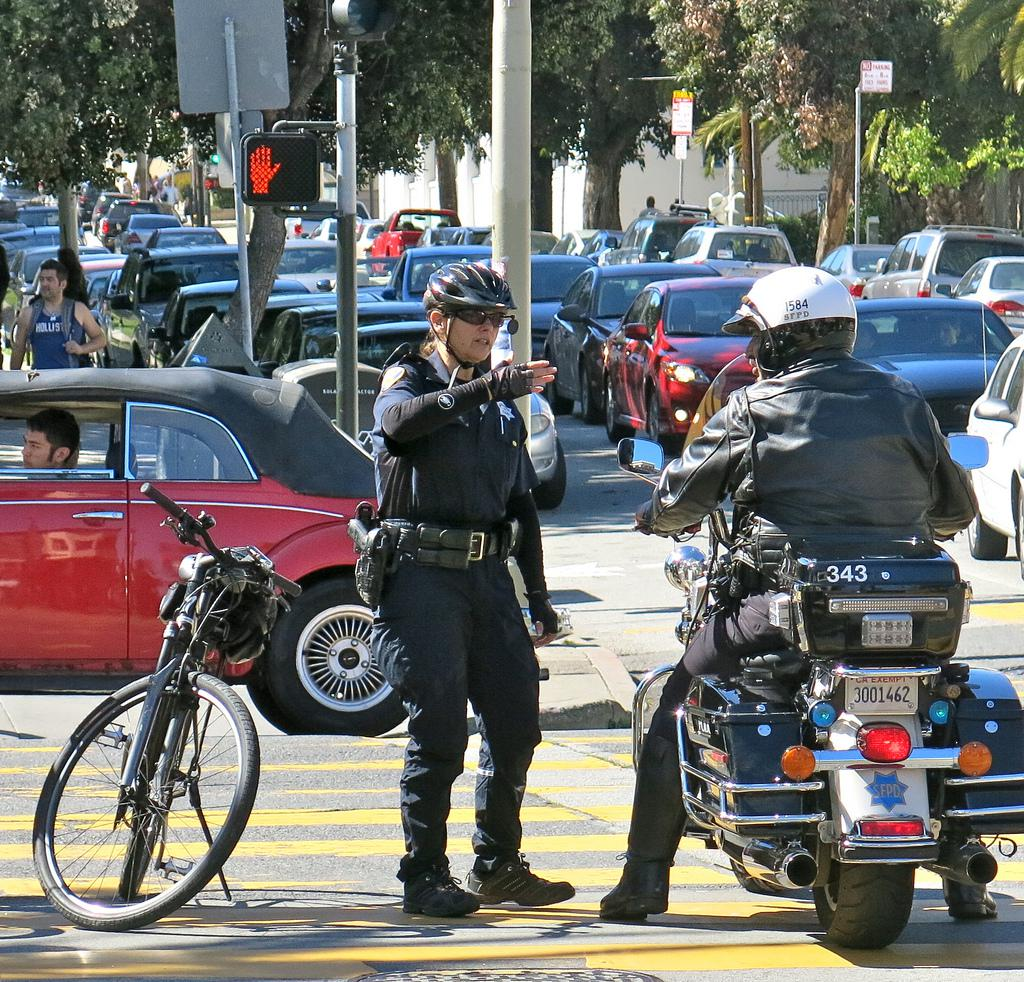Question: when is the light with the red hand going to change?
Choices:
A. In 30 seconds.
B. After all the cross traffic has passed.
C. When the crosswalk button is pushed.
D. Soon.
Answer with the letter. Answer: D Question: why is the red car with the black top have a window down?
Choices:
A. Someone wants to place an order at a drive-thru window.
B. Someone wants to let the air into the car.
C. Someone inside the car wants to speak to someone outside the car.
D. Someone forgot to roll the window up.
Answer with the letter. Answer: B Question: what is the total number of people with helmets that we can see?
Choices:
A. Three.
B. Six.
C. Two.
D. Four.
Answer with the letter. Answer: C Question: what is the total number of motorcycles that we can see?
Choices:
A. Five.
B. Two.
C. Four.
D. One.
Answer with the letter. Answer: D Question: who is gesturing with their right arm?
Choices:
A. The woman talking to the kids.
B. The officer that is standing.
C. The man beside the truck.
D. The guy who is sitting at the table.
Answer with the letter. Answer: B Question: what warns pedestrians to stop?
Choices:
A. When the light turns yellow.
B. The traffic light.
C. When the light turns red.
D. When a hand shows on the signal.
Answer with the letter. Answer: B Question: where is the convertible?
Choices:
A. Passing behind the officer.
B. In the road behind the crowd.
C. Going down the middle of the highway.
D. Parked on the sidewalk behind the couple.
Answer with the letter. Answer: A Question: who is the bike cop talking to?
Choices:
A. The motorcycle cop.
B. The guy on the motorcycle.
C. The kids sitting on the ground.
D. The man in the convertible.
Answer with the letter. Answer: A Question: who is wearing a white helmet?
Choices:
A. The kid on the bicycle.
B. The policeman on the motorcycle.
C. The guy on the moped.
D. The woman on the motorcycle.
Answer with the letter. Answer: B Question: what are many of the vehicles doing?
Choices:
A. Driving.
B. Parking.
C. Getting a car wash.
D. Getting tickets.
Answer with the letter. Answer: A Question: what is the jogging man doing?
Choices:
A. Listening to music.
B. Approaching the intersection.
C. Sprinting.
D. Slowing down.
Answer with the letter. Answer: B Question: what kind of car is the red convertible?
Choices:
A. It's a collectible.
B. Volkswagen.
C. It's a 1972 car.
D. It's remodeled.
Answer with the letter. Answer: B Question: how many parking signs are on the side of the street?
Choices:
A. None.
B. One.
C. Two.
D. Three.
Answer with the letter. Answer: A Question: who is stopped in the crosswalk?
Choices:
A. The hurt man.
B. The man who was bleeding.
C. Police officers.
D. The people who saw the accident.
Answer with the letter. Answer: C Question: who is talking in the crosswalk?
Choices:
A. Firemen.
B. Business men.
C. Meter readers.
D. Cops.
Answer with the letter. Answer: D Question: what lines both sides of street?
Choices:
A. Buildings.
B. Cars.
C. Lamp posts.
D. Trees.
Answer with the letter. Answer: D 